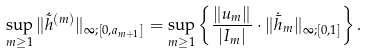<formula> <loc_0><loc_0><loc_500><loc_500>\sup _ { m \geq 1 } \| \dot { \tilde { h } } ^ { ( m ) } \| _ { \infty ; [ 0 , a _ { m + 1 } ] } = \sup _ { m \geq 1 } \left \{ \frac { \| u _ { m } \| } { | I _ { m } | } \cdot \| \dot { \bar { h } } _ { m } \| _ { \infty ; [ 0 , 1 ] } \right \} .</formula> 